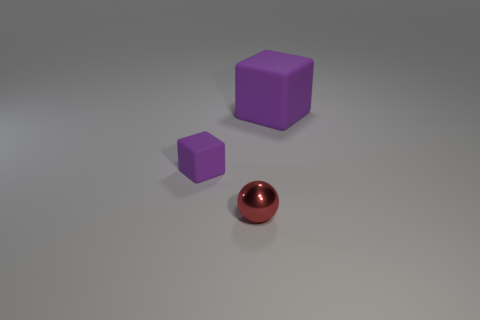Add 3 tiny blocks. How many objects exist? 6 Subtract all spheres. How many objects are left? 2 Add 3 tiny purple matte things. How many tiny purple matte things exist? 4 Subtract 1 purple cubes. How many objects are left? 2 Subtract all big things. Subtract all big cubes. How many objects are left? 1 Add 2 large matte cubes. How many large matte cubes are left? 3 